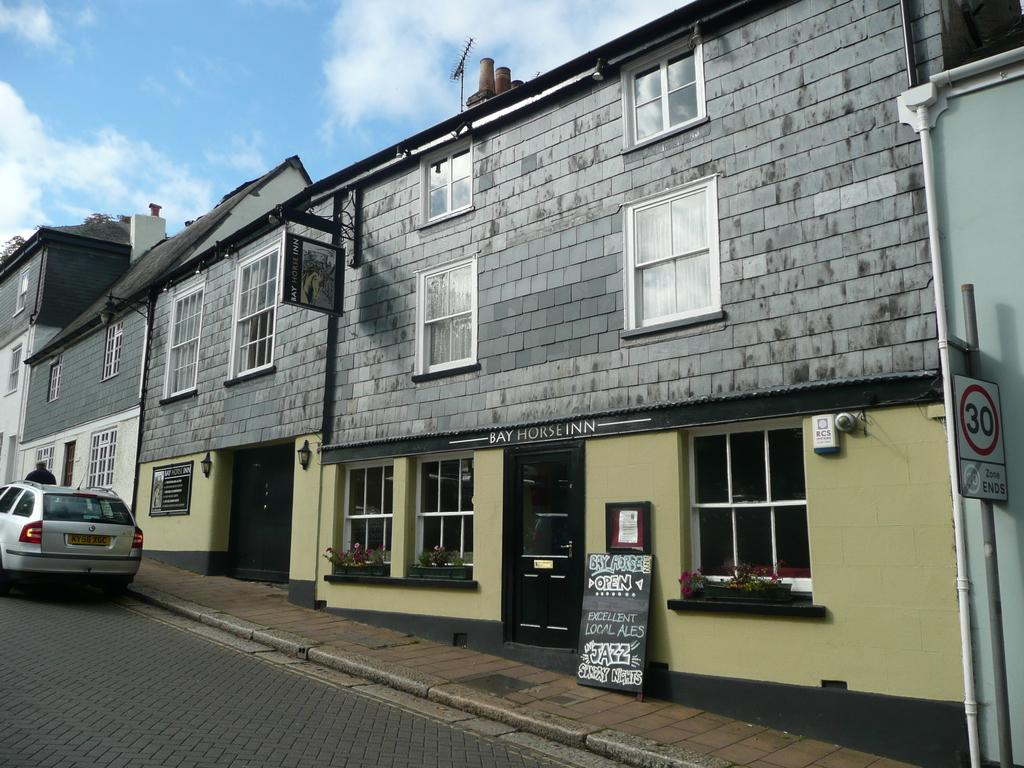What is on the road in the image? There is a vehicle on the road in the image. What can be seen in the background of the image? There are buildings visible in the image. What type of objects are present in the image? There are boards present in the image. Can you see a frog playing with a stick in the image? There is no frog or stick present in the image. 